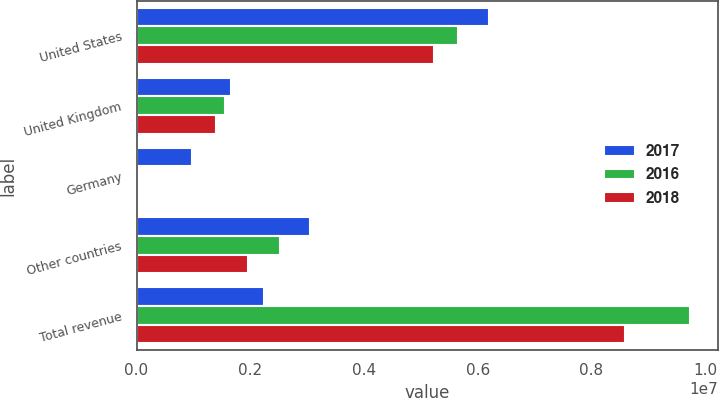Convert chart. <chart><loc_0><loc_0><loc_500><loc_500><stacked_bar_chart><ecel><fcel>United States<fcel>United Kingdom<fcel>Germany<fcel>Other countries<fcel>Total revenue<nl><fcel>2017<fcel>6.19264e+06<fcel>1.66532e+06<fcel>974514<fcel>3.04421e+06<fcel>2.24502e+06<nl><fcel>2016<fcel>5.66202e+06<fcel>1.54821e+06<fcel>1744<fcel>2.52494e+06<fcel>9.73691e+06<nl><fcel>2018<fcel>5.22692e+06<fcel>1.39078e+06<fcel>1227<fcel>1.96511e+06<fcel>8.58403e+06<nl></chart> 